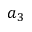<formula> <loc_0><loc_0><loc_500><loc_500>a _ { 3 }</formula> 